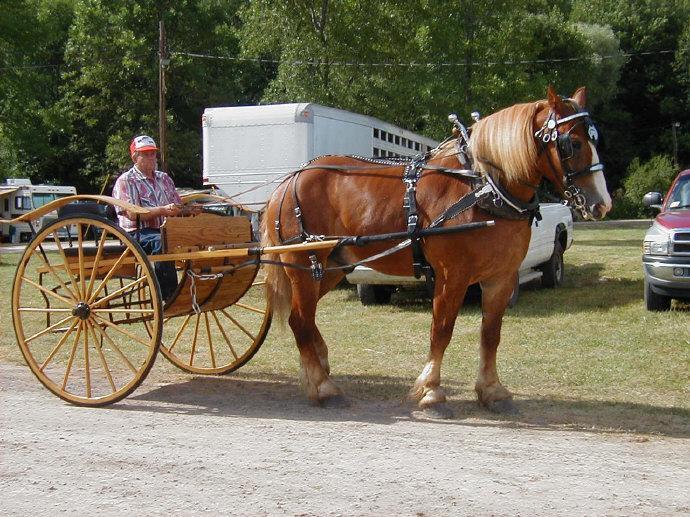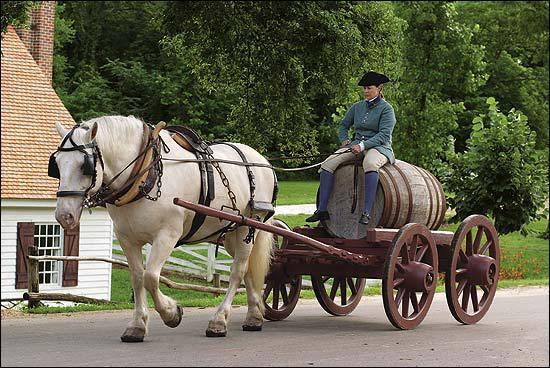The first image is the image on the left, the second image is the image on the right. Examine the images to the left and right. Is the description "There is at least one person in the image on the left." accurate? Answer yes or no. Yes. The first image is the image on the left, the second image is the image on the right. Assess this claim about the two images: "The left image shows a two wheel cart without a person riding in it.". Correct or not? Answer yes or no. No. 